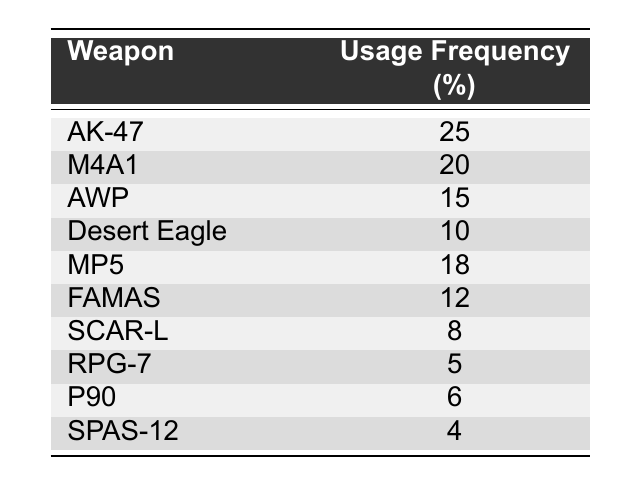What is the most frequently used weapon? The table lists the weapons in order of usage frequency. The weapon with the highest frequency, at 25, is the AK-47.
Answer: AK-47 Which weapon has a usage frequency of 12? Looking for the weapon with a usage frequency of 12, we find it associated with the FAMAS in the table.
Answer: FAMAS How many weapons have a usage frequency greater than 10? The table shows that the AK-47, M4A1, AWP, MP5, and Desert Eagle have usage frequencies of 25, 20, 15, 18, and 10, respectively. That totals five weapons with a frequency greater than 10.
Answer: 5 What is the average usage frequency of the weapons listed? The total usage frequencies are 25 + 20 + 15 + 10 + 18 + 12 + 8 + 5 + 6 + 4 = 118. There are 10 weapons, so the average is 118/10 = 11.8.
Answer: 11.8 Is the RPG-7 used more frequently than the P90? The usage frequency of the RPG-7 is 5 and for the P90 it is 6. Since 5 is less than 6, the statement is false.
Answer: No 